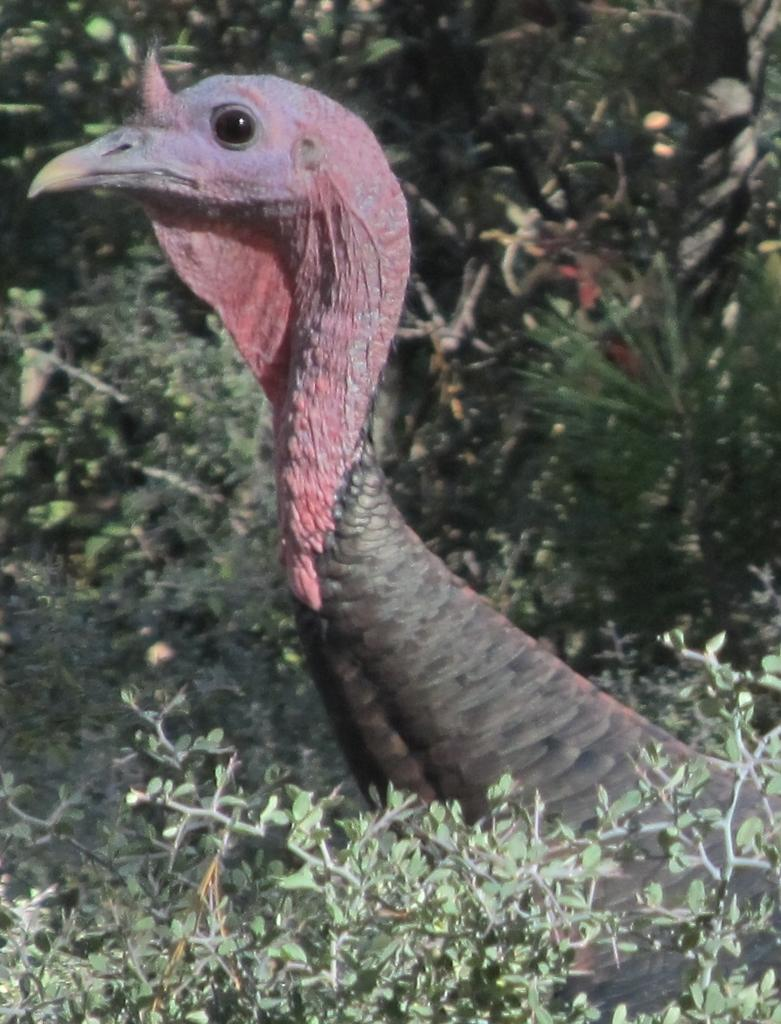What type of animal can be seen in the image? There is a bird in the image. What other living organisms are present in the image? There are plants in the image. What part of the plants can be seen in the image? Leaves are present in the image. What type of leather can be seen in the image? There is no leather present in the image. What kind of notebook is visible in the image? There is no notebook present in the image. 